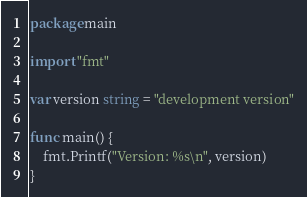<code> <loc_0><loc_0><loc_500><loc_500><_Go_>package main

import "fmt"

var version string = "development version"

func main() {
	fmt.Printf("Version: %s\n", version)
}
</code> 